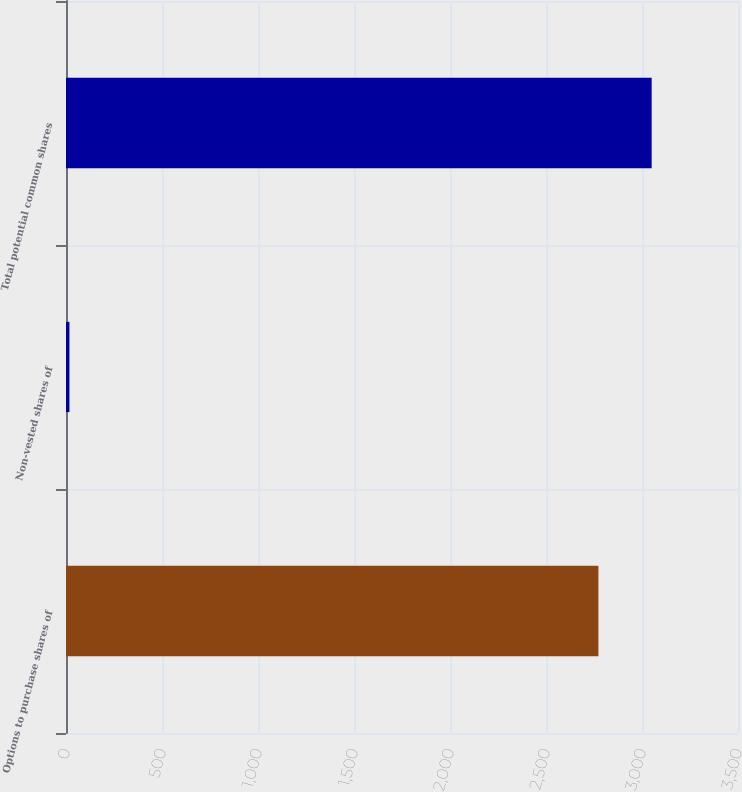<chart> <loc_0><loc_0><loc_500><loc_500><bar_chart><fcel>Options to purchase shares of<fcel>Non-vested shares of<fcel>Total potential common shares<nl><fcel>2773<fcel>18<fcel>3050.3<nl></chart> 